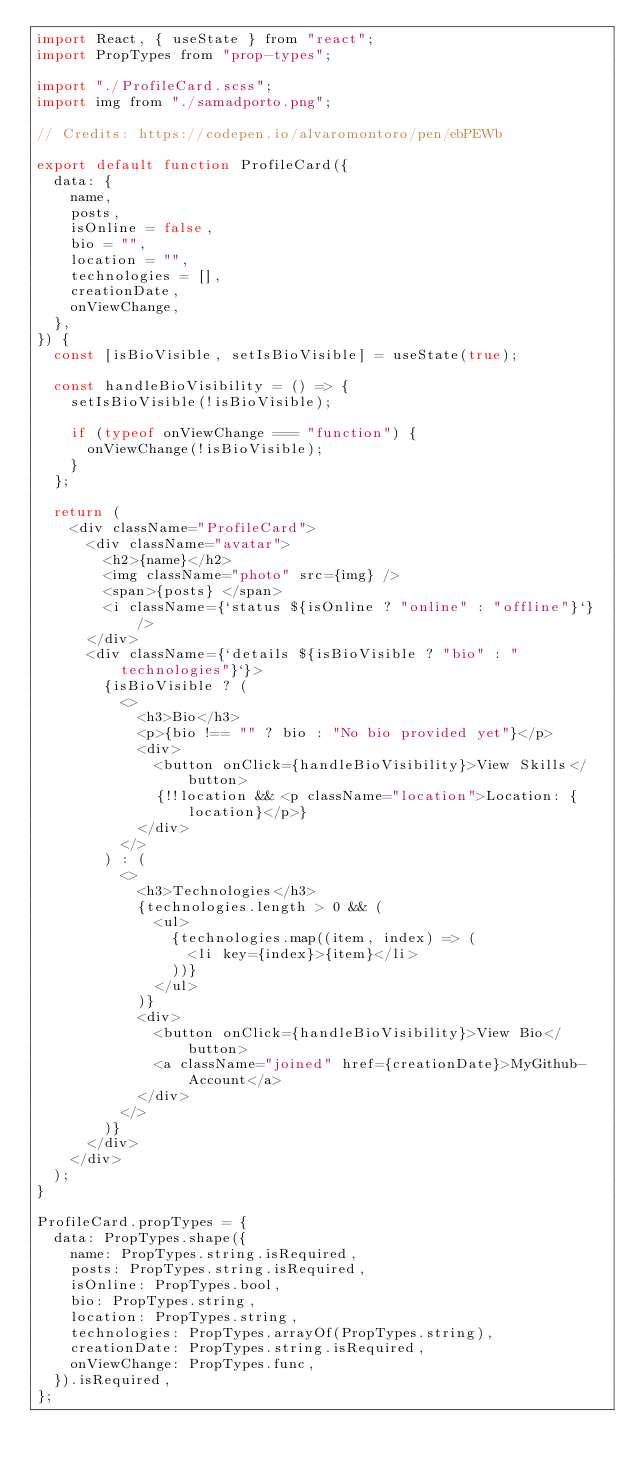Convert code to text. <code><loc_0><loc_0><loc_500><loc_500><_JavaScript_>import React, { useState } from "react";
import PropTypes from "prop-types";

import "./ProfileCard.scss";
import img from "./samadporto.png";

// Credits: https://codepen.io/alvaromontoro/pen/ebPEWb

export default function ProfileCard({
  data: {
    name,
    posts,
    isOnline = false,
    bio = "",
    location = "",
    technologies = [],
    creationDate,
    onViewChange,
  },
}) {
  const [isBioVisible, setIsBioVisible] = useState(true);

  const handleBioVisibility = () => {
    setIsBioVisible(!isBioVisible);

    if (typeof onViewChange === "function") {
      onViewChange(!isBioVisible);
    }
  };

  return (
    <div className="ProfileCard">
      <div className="avatar">
        <h2>{name}</h2>
        <img className="photo" src={img} />
        <span>{posts} </span>
        <i className={`status ${isOnline ? "online" : "offline"}`} />
      </div>
      <div className={`details ${isBioVisible ? "bio" : "technologies"}`}>
        {isBioVisible ? (
          <>
            <h3>Bio</h3>
            <p>{bio !== "" ? bio : "No bio provided yet"}</p>
            <div>
              <button onClick={handleBioVisibility}>View Skills</button>
              {!!location && <p className="location">Location: {location}</p>}
            </div>
          </>
        ) : (
          <>
            <h3>Technologies</h3>
            {technologies.length > 0 && (
              <ul>
                {technologies.map((item, index) => (
                  <li key={index}>{item}</li>
                ))}
              </ul>
            )}
            <div>
              <button onClick={handleBioVisibility}>View Bio</button>
              <a className="joined" href={creationDate}>MyGithub-Account</a>
            </div>
          </>
        )}
      </div>
    </div>
  );
}

ProfileCard.propTypes = {
  data: PropTypes.shape({
    name: PropTypes.string.isRequired,
    posts: PropTypes.string.isRequired,
    isOnline: PropTypes.bool,
    bio: PropTypes.string,
    location: PropTypes.string,
    technologies: PropTypes.arrayOf(PropTypes.string),
    creationDate: PropTypes.string.isRequired,
    onViewChange: PropTypes.func,
  }).isRequired,
};
</code> 